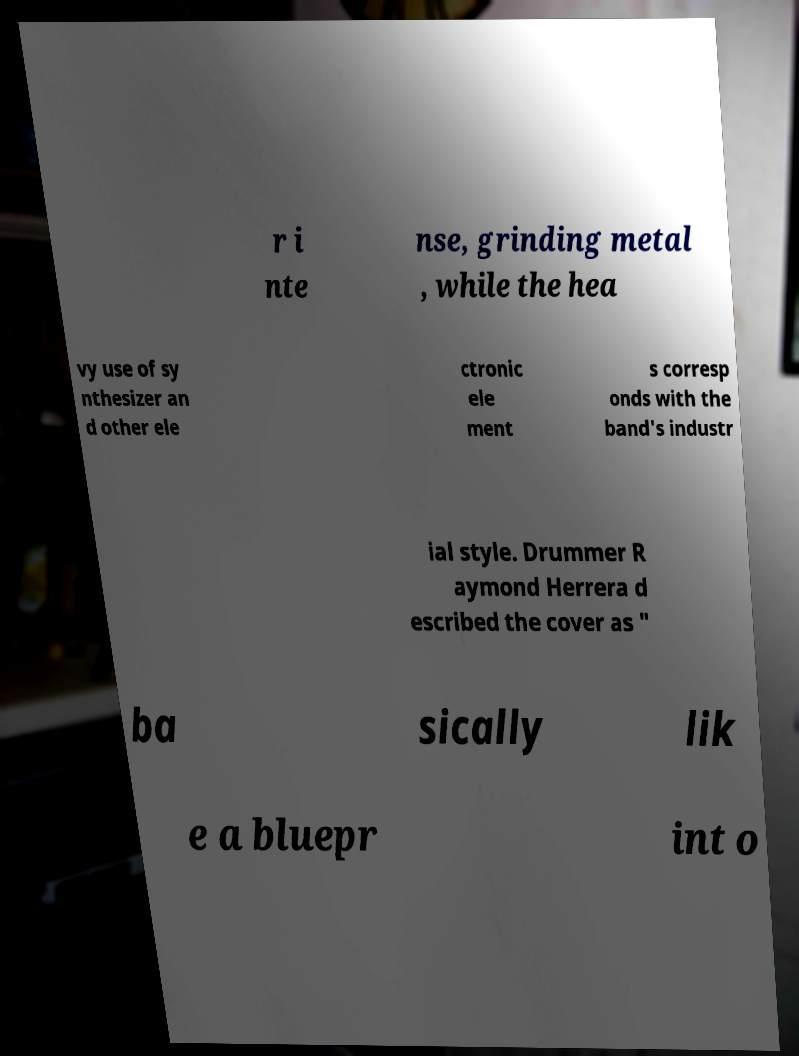Could you assist in decoding the text presented in this image and type it out clearly? r i nte nse, grinding metal , while the hea vy use of sy nthesizer an d other ele ctronic ele ment s corresp onds with the band's industr ial style. Drummer R aymond Herrera d escribed the cover as " ba sically lik e a bluepr int o 